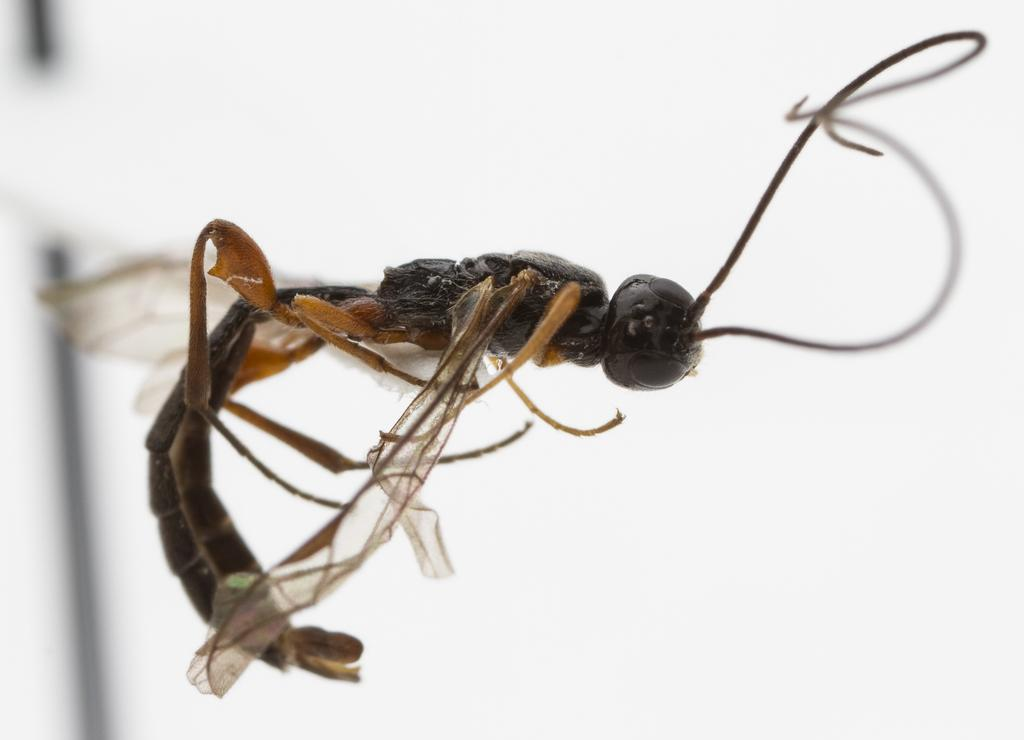What type of creature can be seen in the image? There is an insect in the image. What type of shoe is the insect wearing in the image? There is no shoe present in the image, as it features an insect and not a person or animal wearing clothing. 